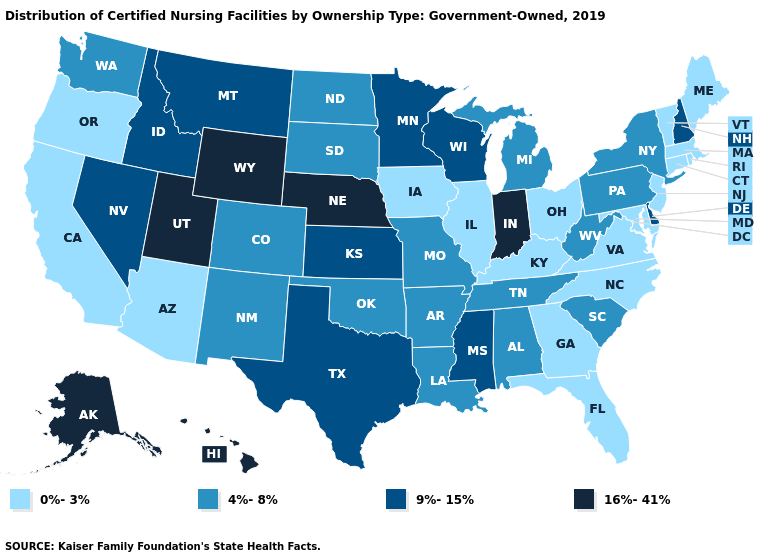Which states have the highest value in the USA?
Give a very brief answer. Alaska, Hawaii, Indiana, Nebraska, Utah, Wyoming. Does Vermont have the lowest value in the USA?
Concise answer only. Yes. Name the states that have a value in the range 16%-41%?
Give a very brief answer. Alaska, Hawaii, Indiana, Nebraska, Utah, Wyoming. Among the states that border Alabama , does Tennessee have the highest value?
Be succinct. No. Does North Carolina have the same value as New Mexico?
Concise answer only. No. What is the value of Ohio?
Answer briefly. 0%-3%. Does Kentucky have the highest value in the USA?
Quick response, please. No. Does the map have missing data?
Write a very short answer. No. Does Missouri have the highest value in the MidWest?
Give a very brief answer. No. Name the states that have a value in the range 0%-3%?
Concise answer only. Arizona, California, Connecticut, Florida, Georgia, Illinois, Iowa, Kentucky, Maine, Maryland, Massachusetts, New Jersey, North Carolina, Ohio, Oregon, Rhode Island, Vermont, Virginia. Name the states that have a value in the range 0%-3%?
Concise answer only. Arizona, California, Connecticut, Florida, Georgia, Illinois, Iowa, Kentucky, Maine, Maryland, Massachusetts, New Jersey, North Carolina, Ohio, Oregon, Rhode Island, Vermont, Virginia. Which states have the highest value in the USA?
Keep it brief. Alaska, Hawaii, Indiana, Nebraska, Utah, Wyoming. What is the highest value in the Northeast ?
Short answer required. 9%-15%. Does New Mexico have the lowest value in the USA?
Concise answer only. No. What is the lowest value in the Northeast?
Give a very brief answer. 0%-3%. 